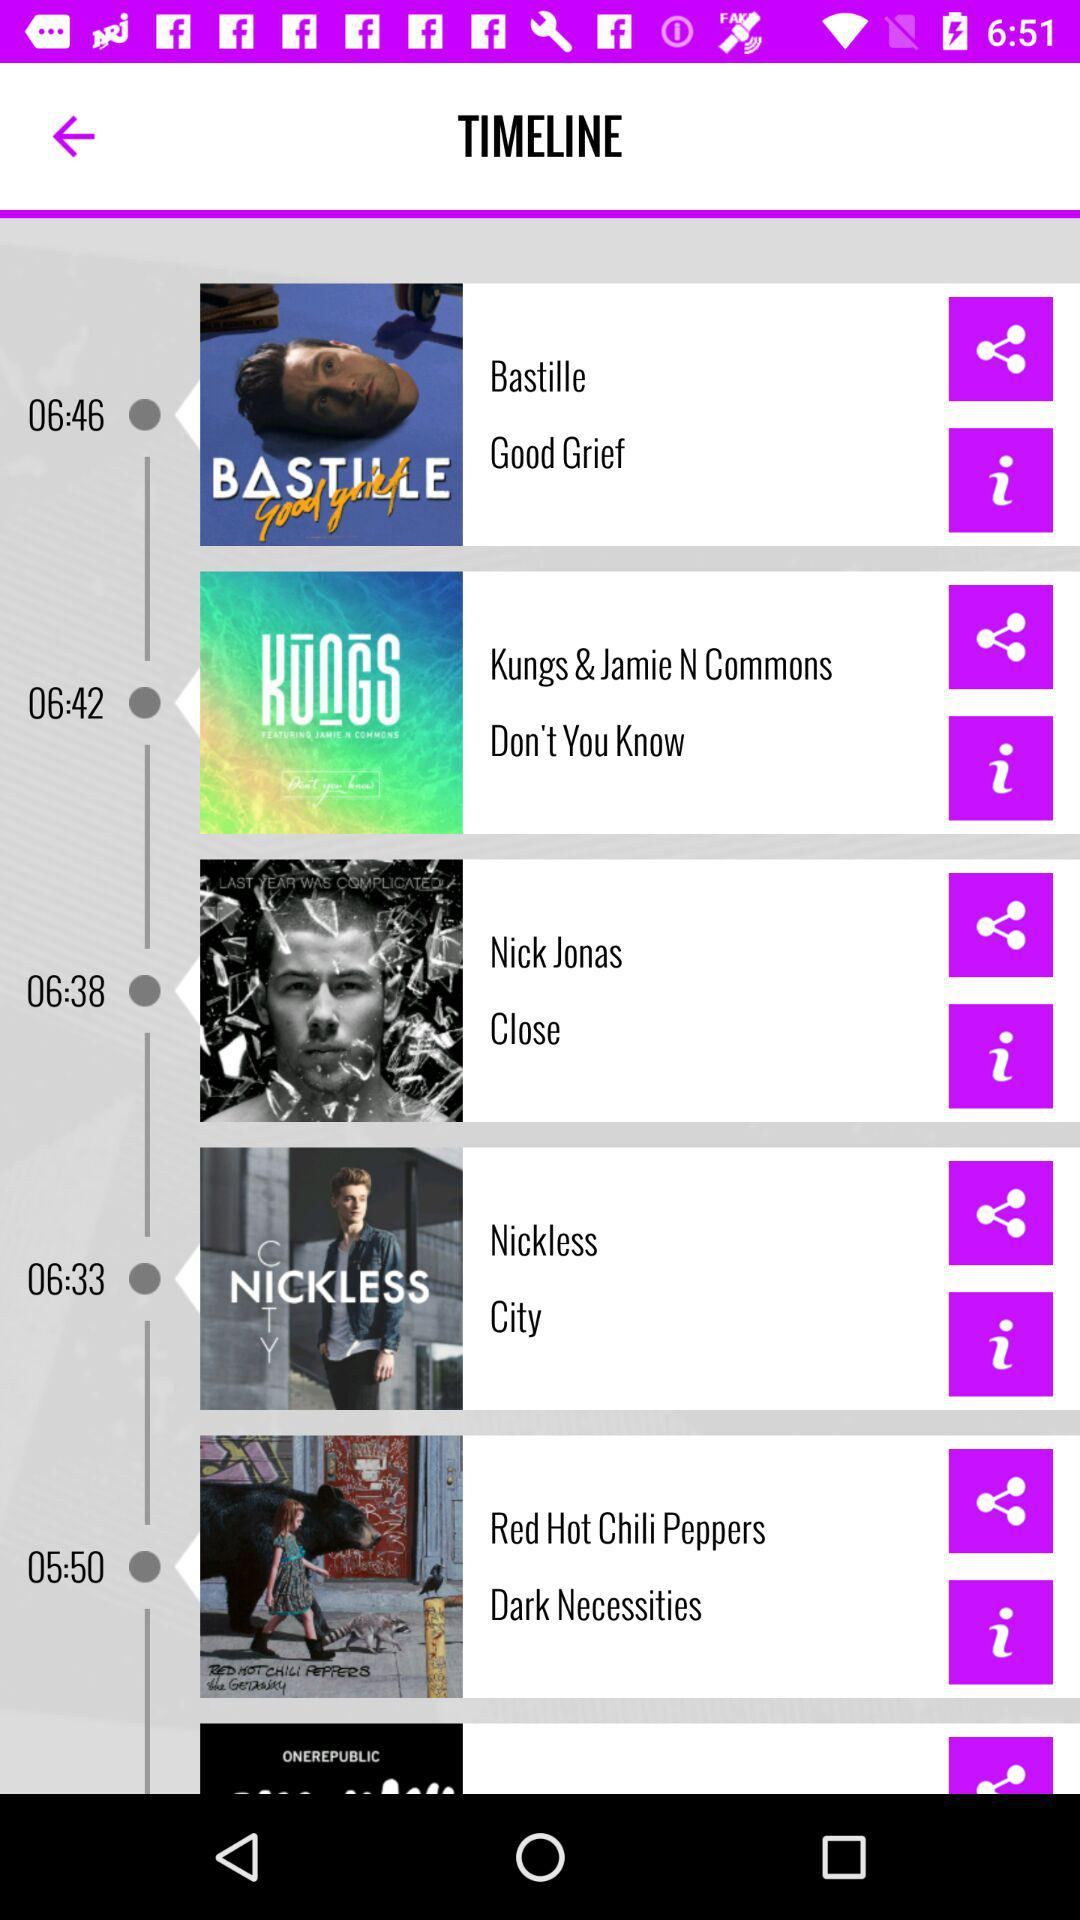What is the name of the vocalist for the song "Close"? The name of the vocalist is Nick Jonas. 